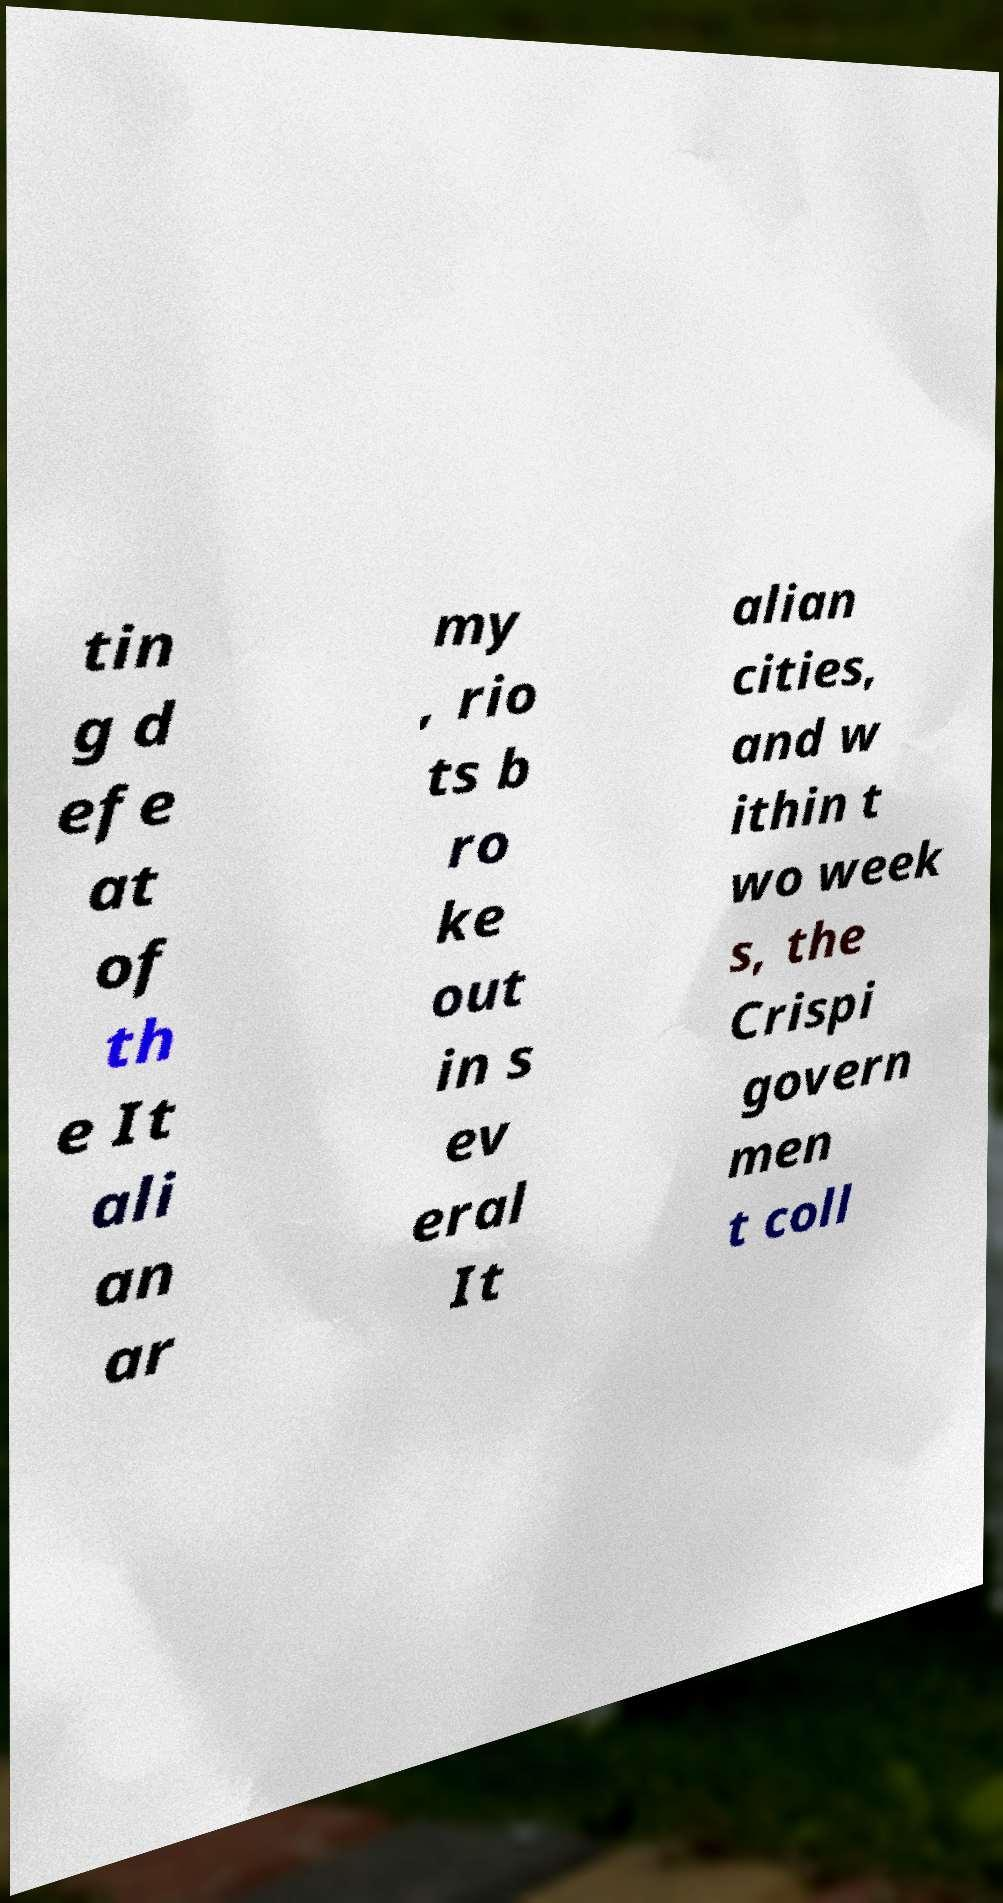For documentation purposes, I need the text within this image transcribed. Could you provide that? tin g d efe at of th e It ali an ar my , rio ts b ro ke out in s ev eral It alian cities, and w ithin t wo week s, the Crispi govern men t coll 